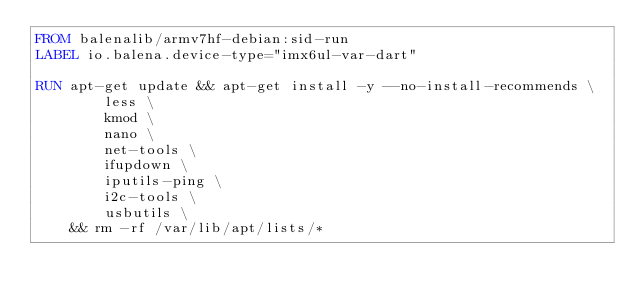Convert code to text. <code><loc_0><loc_0><loc_500><loc_500><_Dockerfile_>FROM balenalib/armv7hf-debian:sid-run
LABEL io.balena.device-type="imx6ul-var-dart"

RUN apt-get update && apt-get install -y --no-install-recommends \
		less \
		kmod \
		nano \
		net-tools \
		ifupdown \
		iputils-ping \
		i2c-tools \
		usbutils \
	&& rm -rf /var/lib/apt/lists/*</code> 